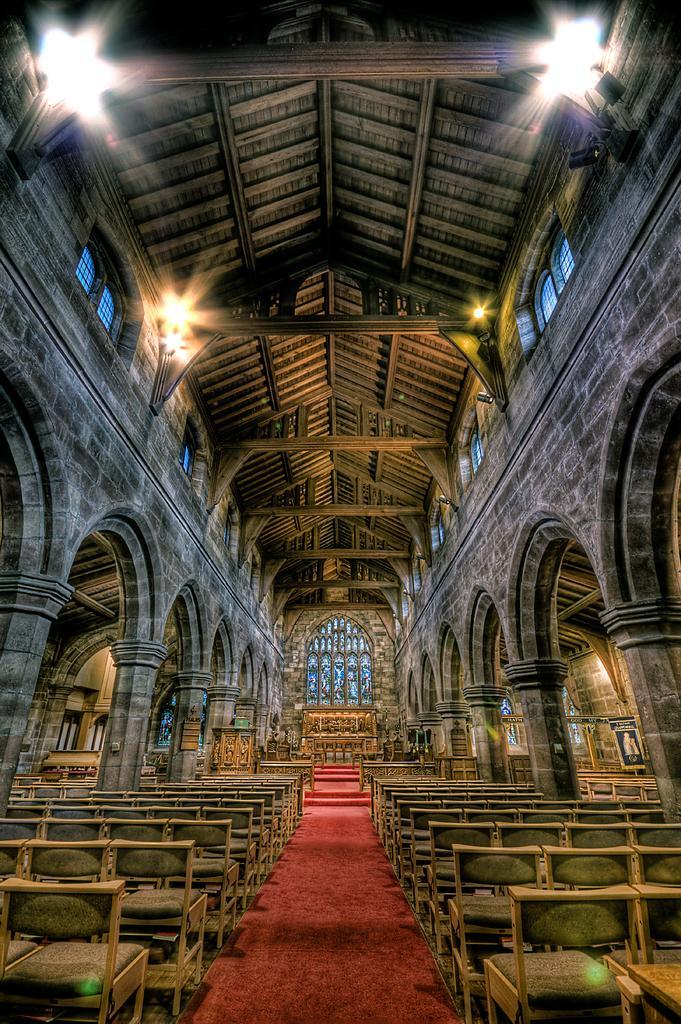How would you summarize this image in a sentence or two? This is the inside view of a building. Here we can see chairs, pillows, and lights. 